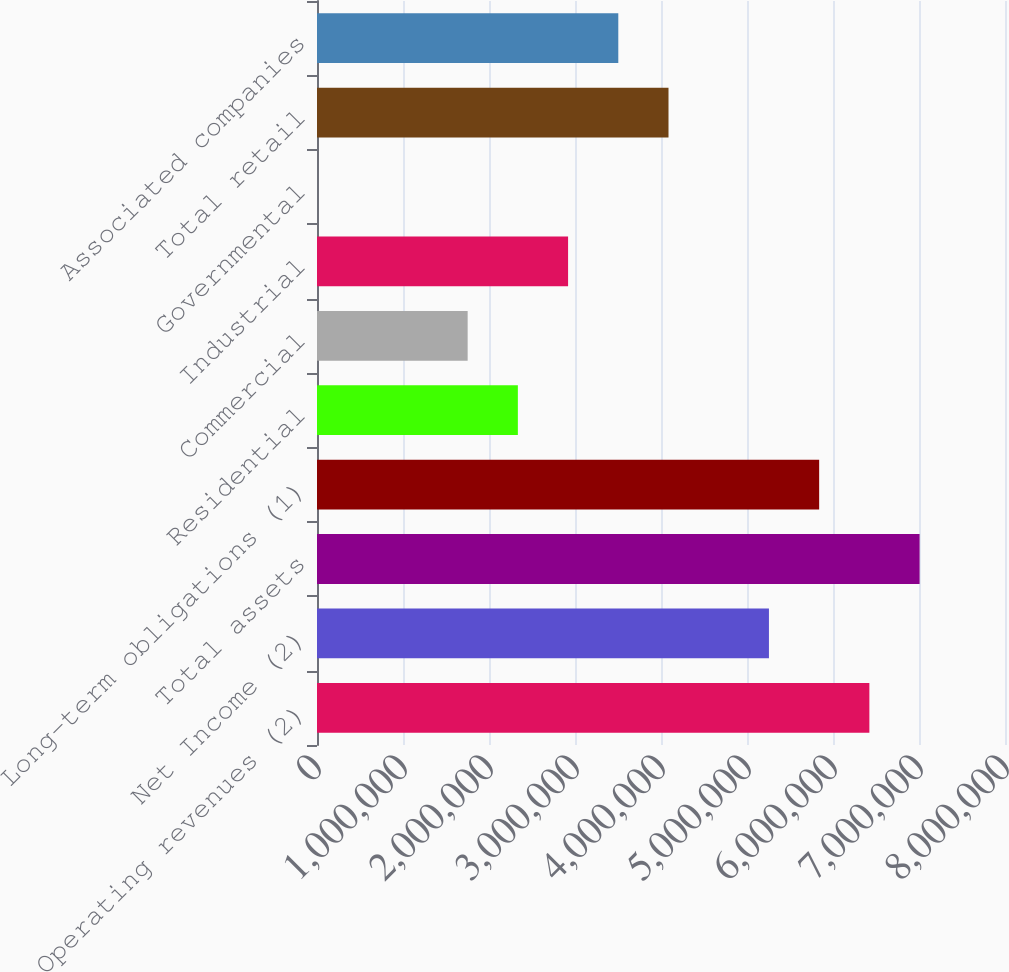Convert chart. <chart><loc_0><loc_0><loc_500><loc_500><bar_chart><fcel>Operating revenues (2)<fcel>Net Income (2)<fcel>Total assets<fcel>Long-term obligations (1)<fcel>Residential<fcel>Commercial<fcel>Industrial<fcel>Governmental<fcel>Total retail<fcel>Associated companies<nl><fcel>6.42296e+06<fcel>5.25515e+06<fcel>7.00686e+06<fcel>5.83905e+06<fcel>2.33563e+06<fcel>1.75173e+06<fcel>2.91954e+06<fcel>22<fcel>4.08734e+06<fcel>3.50344e+06<nl></chart> 